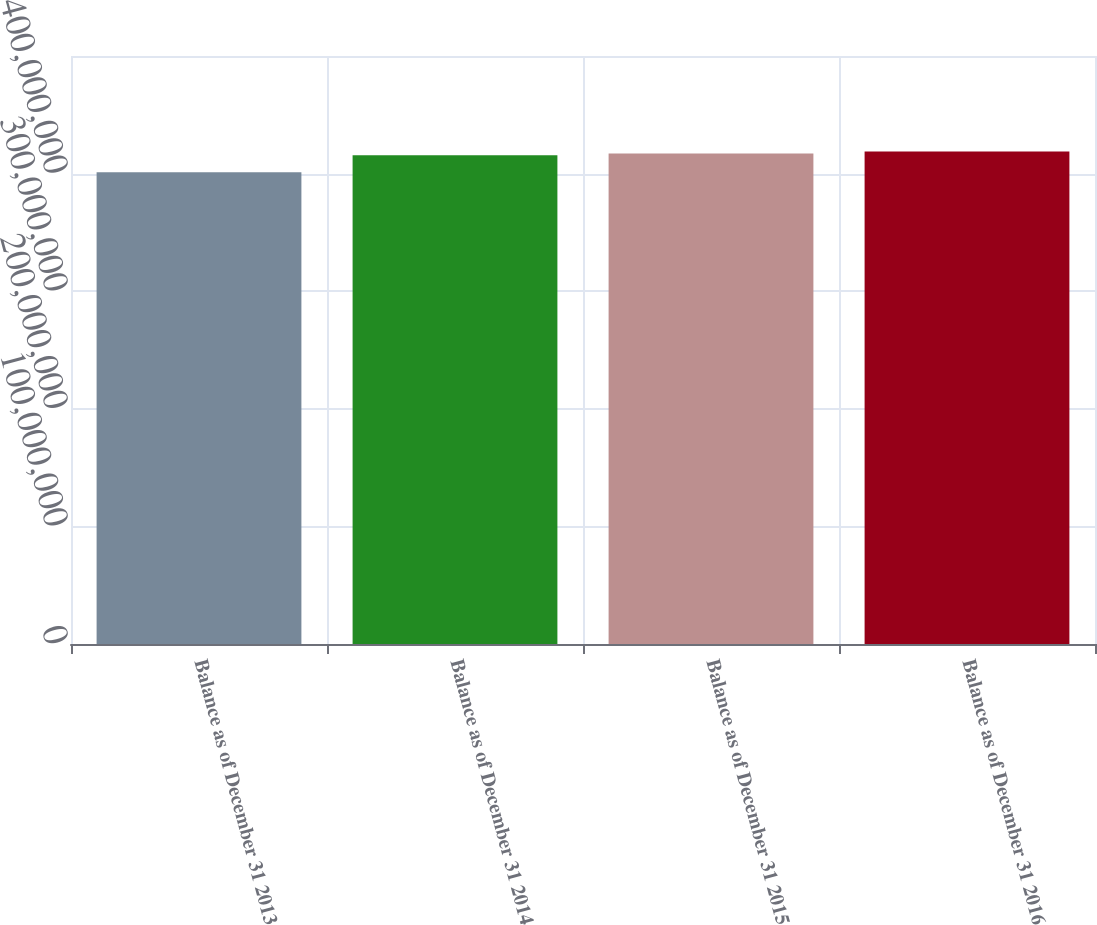Convert chart to OTSL. <chart><loc_0><loc_0><loc_500><loc_500><bar_chart><fcel>Balance as of December 31 2013<fcel>Balance as of December 31 2014<fcel>Balance as of December 31 2015<fcel>Balance as of December 31 2016<nl><fcel>4.01127e+08<fcel>4.15506e+08<fcel>4.17152e+08<fcel>4.18798e+08<nl></chart> 